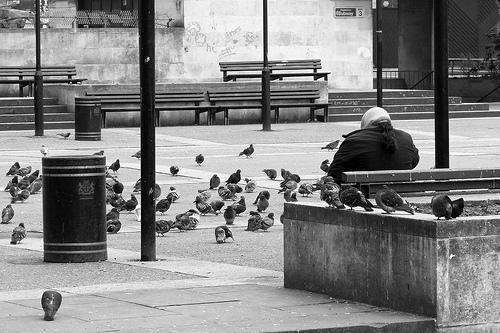How many people are in the picture?
Give a very brief answer. 1. How many trash cans are in the picture?
Give a very brief answer. 2. 